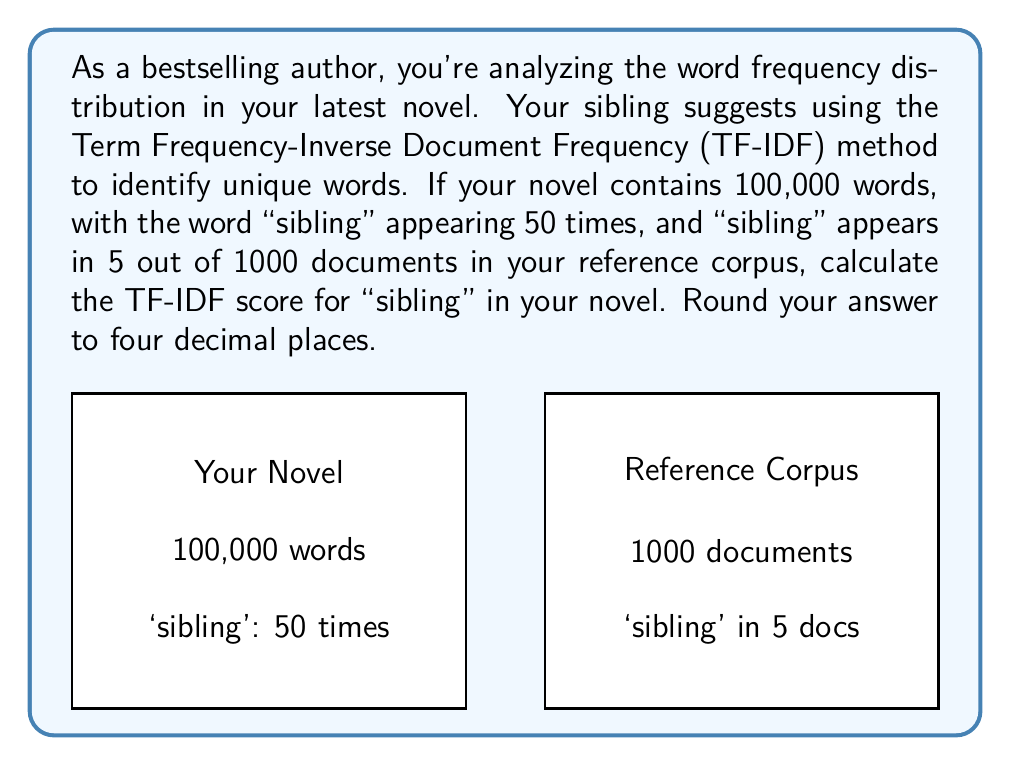Provide a solution to this math problem. To calculate the TF-IDF score, we need to follow these steps:

1. Calculate Term Frequency (TF):
   $TF = \frac{\text{Number of times "sibling" appears in the novel}}{\text{Total number of words in the novel}}$
   $TF = \frac{50}{100,000} = 0.0005$

2. Calculate Inverse Document Frequency (IDF):
   $IDF = \log\left(\frac{\text{Total number of documents}}{\text{Number of documents containing "sibling"}}\right)$
   $IDF = \log\left(\frac{1000}{5}\right) = \log(200) \approx 5.2983$

3. Calculate TF-IDF:
   $TF\text{-}IDF = TF \times IDF$
   $TF\text{-}IDF = 0.0005 \times 5.2983 \approx 0.0026491$

4. Round to four decimal places:
   $0.0026491 \approx 0.0026$

Therefore, the TF-IDF score for "sibling" in your novel is approximately 0.0026.
Answer: 0.0026 